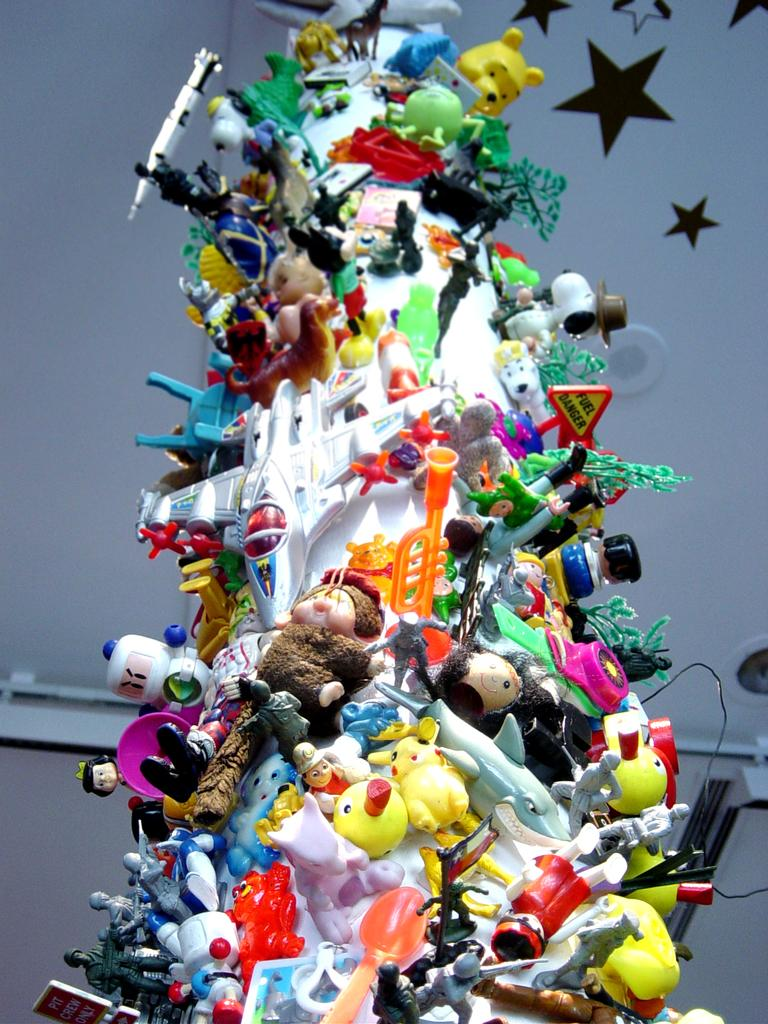What is hanging on the wall in the image? There are many toys on the wall in the image. Can you describe any specific details about the wall? There are stars on the wall at the right top of the image. How many dimes are placed on the side of the toys in the image? There are no dimes present in the image. What is the head count of the toys on the wall in the image? The provided facts do not give information about the number of toys, so we cannot determine the head count. 